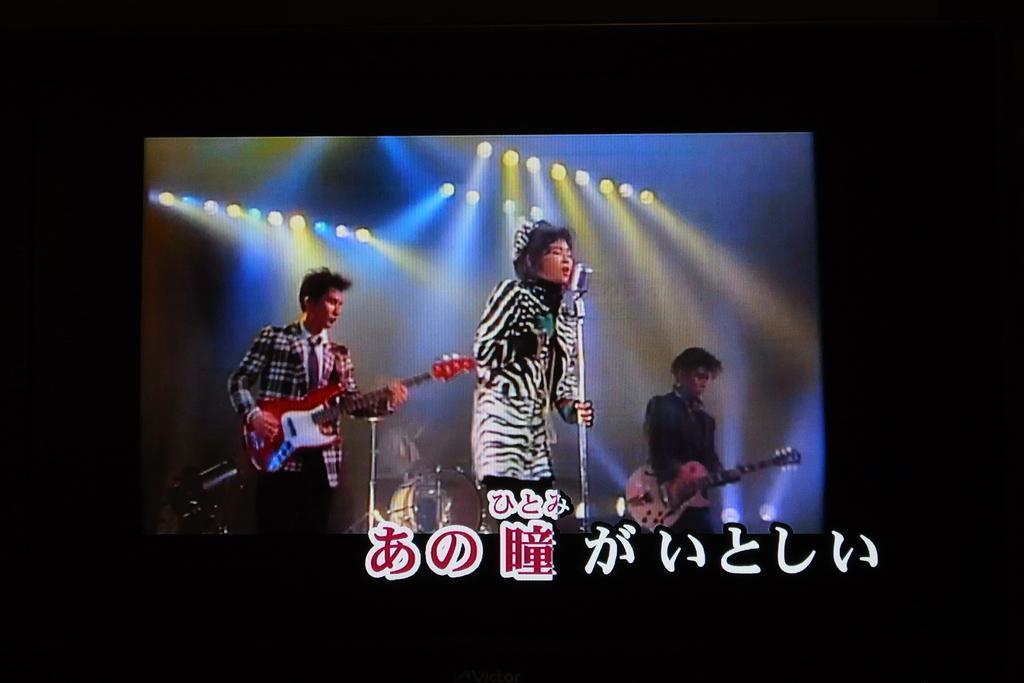How would you summarize this image in a sentence or two? In this picture, we can see the screen, we can see three persons, and among them two are holding musical instruments and one person is holding micro phone, we can see musical instruments and lights in the background, and some text in the bottom side of the picture. 